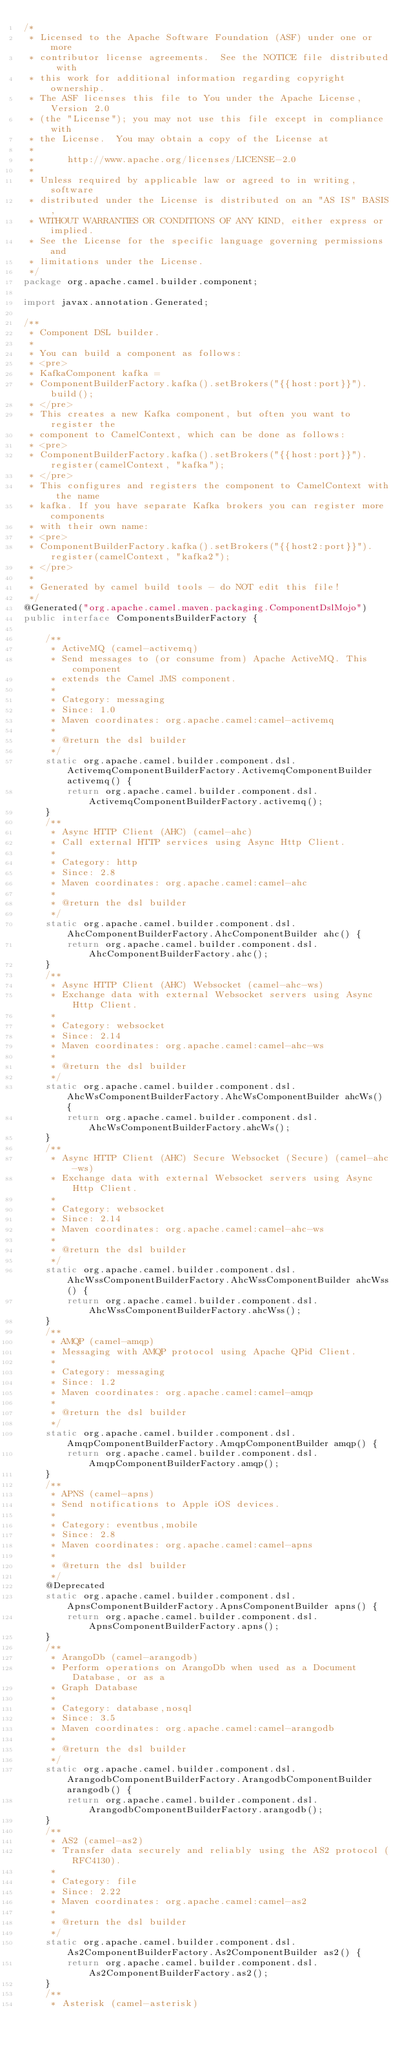Convert code to text. <code><loc_0><loc_0><loc_500><loc_500><_Java_>/*
 * Licensed to the Apache Software Foundation (ASF) under one or more
 * contributor license agreements.  See the NOTICE file distributed with
 * this work for additional information regarding copyright ownership.
 * The ASF licenses this file to You under the Apache License, Version 2.0
 * (the "License"); you may not use this file except in compliance with
 * the License.  You may obtain a copy of the License at
 *
 *      http://www.apache.org/licenses/LICENSE-2.0
 *
 * Unless required by applicable law or agreed to in writing, software
 * distributed under the License is distributed on an "AS IS" BASIS,
 * WITHOUT WARRANTIES OR CONDITIONS OF ANY KIND, either express or implied.
 * See the License for the specific language governing permissions and
 * limitations under the License.
 */
package org.apache.camel.builder.component;

import javax.annotation.Generated;

/**
 * Component DSL builder.
 * 
 * You can build a component as follows:
 * <pre>
 * KafkaComponent kafka =
 * ComponentBuilderFactory.kafka().setBrokers("{{host:port}}").build();
 * </pre>
 * This creates a new Kafka component, but often you want to register the
 * component to CamelContext, which can be done as follows:
 * <pre>
 * ComponentBuilderFactory.kafka().setBrokers("{{host:port}}").register(camelContext, "kafka");
 * </pre>
 * This configures and registers the component to CamelContext with the name
 * kafka. If you have separate Kafka brokers you can register more components
 * with their own name:
 * <pre>
 * ComponentBuilderFactory.kafka().setBrokers("{{host2:port}}").register(camelContext, "kafka2");
 * </pre>
 * 
 * Generated by camel build tools - do NOT edit this file!
 */
@Generated("org.apache.camel.maven.packaging.ComponentDslMojo")
public interface ComponentsBuilderFactory {

    /**
     * ActiveMQ (camel-activemq)
     * Send messages to (or consume from) Apache ActiveMQ. This component
     * extends the Camel JMS component.
     * 
     * Category: messaging
     * Since: 1.0
     * Maven coordinates: org.apache.camel:camel-activemq
     * 
     * @return the dsl builder
     */
    static org.apache.camel.builder.component.dsl.ActivemqComponentBuilderFactory.ActivemqComponentBuilder activemq() {
        return org.apache.camel.builder.component.dsl.ActivemqComponentBuilderFactory.activemq();
    }
    /**
     * Async HTTP Client (AHC) (camel-ahc)
     * Call external HTTP services using Async Http Client.
     * 
     * Category: http
     * Since: 2.8
     * Maven coordinates: org.apache.camel:camel-ahc
     * 
     * @return the dsl builder
     */
    static org.apache.camel.builder.component.dsl.AhcComponentBuilderFactory.AhcComponentBuilder ahc() {
        return org.apache.camel.builder.component.dsl.AhcComponentBuilderFactory.ahc();
    }
    /**
     * Async HTTP Client (AHC) Websocket (camel-ahc-ws)
     * Exchange data with external Websocket servers using Async Http Client.
     * 
     * Category: websocket
     * Since: 2.14
     * Maven coordinates: org.apache.camel:camel-ahc-ws
     * 
     * @return the dsl builder
     */
    static org.apache.camel.builder.component.dsl.AhcWsComponentBuilderFactory.AhcWsComponentBuilder ahcWs() {
        return org.apache.camel.builder.component.dsl.AhcWsComponentBuilderFactory.ahcWs();
    }
    /**
     * Async HTTP Client (AHC) Secure Websocket (Secure) (camel-ahc-ws)
     * Exchange data with external Websocket servers using Async Http Client.
     * 
     * Category: websocket
     * Since: 2.14
     * Maven coordinates: org.apache.camel:camel-ahc-ws
     * 
     * @return the dsl builder
     */
    static org.apache.camel.builder.component.dsl.AhcWssComponentBuilderFactory.AhcWssComponentBuilder ahcWss() {
        return org.apache.camel.builder.component.dsl.AhcWssComponentBuilderFactory.ahcWss();
    }
    /**
     * AMQP (camel-amqp)
     * Messaging with AMQP protocol using Apache QPid Client.
     * 
     * Category: messaging
     * Since: 1.2
     * Maven coordinates: org.apache.camel:camel-amqp
     * 
     * @return the dsl builder
     */
    static org.apache.camel.builder.component.dsl.AmqpComponentBuilderFactory.AmqpComponentBuilder amqp() {
        return org.apache.camel.builder.component.dsl.AmqpComponentBuilderFactory.amqp();
    }
    /**
     * APNS (camel-apns)
     * Send notifications to Apple iOS devices.
     * 
     * Category: eventbus,mobile
     * Since: 2.8
     * Maven coordinates: org.apache.camel:camel-apns
     * 
     * @return the dsl builder
     */
    @Deprecated
    static org.apache.camel.builder.component.dsl.ApnsComponentBuilderFactory.ApnsComponentBuilder apns() {
        return org.apache.camel.builder.component.dsl.ApnsComponentBuilderFactory.apns();
    }
    /**
     * ArangoDb (camel-arangodb)
     * Perform operations on ArangoDb when used as a Document Database, or as a
     * Graph Database
     * 
     * Category: database,nosql
     * Since: 3.5
     * Maven coordinates: org.apache.camel:camel-arangodb
     * 
     * @return the dsl builder
     */
    static org.apache.camel.builder.component.dsl.ArangodbComponentBuilderFactory.ArangodbComponentBuilder arangodb() {
        return org.apache.camel.builder.component.dsl.ArangodbComponentBuilderFactory.arangodb();
    }
    /**
     * AS2 (camel-as2)
     * Transfer data securely and reliably using the AS2 protocol (RFC4130).
     * 
     * Category: file
     * Since: 2.22
     * Maven coordinates: org.apache.camel:camel-as2
     * 
     * @return the dsl builder
     */
    static org.apache.camel.builder.component.dsl.As2ComponentBuilderFactory.As2ComponentBuilder as2() {
        return org.apache.camel.builder.component.dsl.As2ComponentBuilderFactory.as2();
    }
    /**
     * Asterisk (camel-asterisk)</code> 